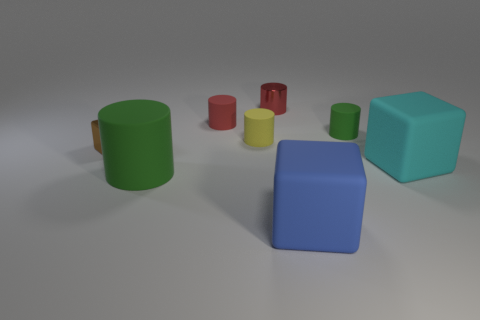The thing that is the same color as the metallic cylinder is what size?
Your answer should be compact. Small. Are there fewer red rubber cylinders that are behind the large green thing than small cyan rubber objects?
Your answer should be compact. No. Are there any big green cylinders?
Your response must be concise. Yes. The other metal object that is the same shape as the small green thing is what color?
Provide a succinct answer. Red. Is the color of the metallic thing that is to the right of the red rubber thing the same as the small block?
Your response must be concise. No. Do the blue matte block and the cyan thing have the same size?
Your response must be concise. Yes. What shape is the tiny red object that is the same material as the tiny brown cube?
Give a very brief answer. Cylinder. What number of other objects are there of the same shape as the big blue thing?
Your answer should be very brief. 2. There is a rubber object that is to the right of the green cylinder that is behind the big cyan block right of the brown shiny object; what shape is it?
Your response must be concise. Cube. How many cylinders are big blue things or green objects?
Offer a very short reply. 2. 